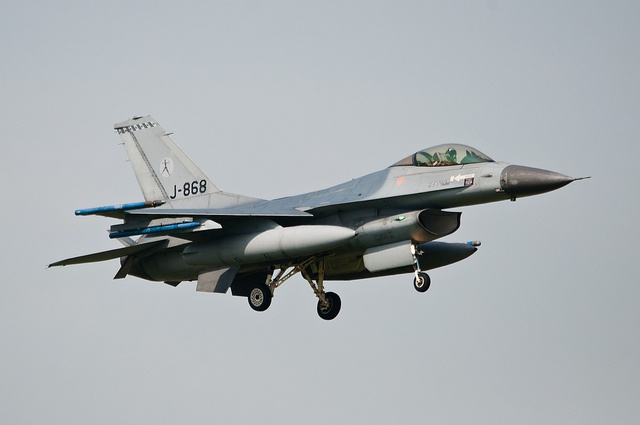Describe the objects in this image and their specific colors. I can see airplane in darkgray, black, lightgray, and gray tones and people in darkgray, gray, teal, and black tones in this image. 